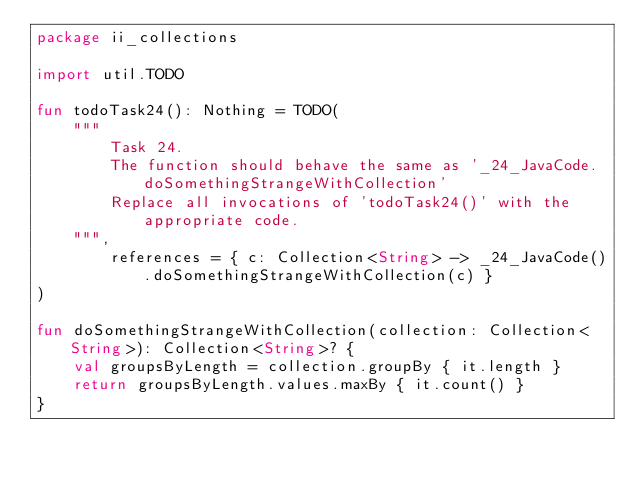Convert code to text. <code><loc_0><loc_0><loc_500><loc_500><_Kotlin_>package ii_collections

import util.TODO

fun todoTask24(): Nothing = TODO(
    """
        Task 24.
        The function should behave the same as '_24_JavaCode.doSomethingStrangeWithCollection'
        Replace all invocations of 'todoTask24()' with the appropriate code.
    """,
        references = { c: Collection<String> -> _24_JavaCode().doSomethingStrangeWithCollection(c) }
)

fun doSomethingStrangeWithCollection(collection: Collection<String>): Collection<String>? {
    val groupsByLength = collection.groupBy { it.length }
    return groupsByLength.values.maxBy { it.count() }
}

</code> 